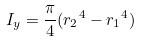<formula> <loc_0><loc_0><loc_500><loc_500>I _ { y } = \frac { \pi } { 4 } ( { r _ { 2 } } ^ { 4 } - { r _ { 1 } } ^ { 4 } )</formula> 